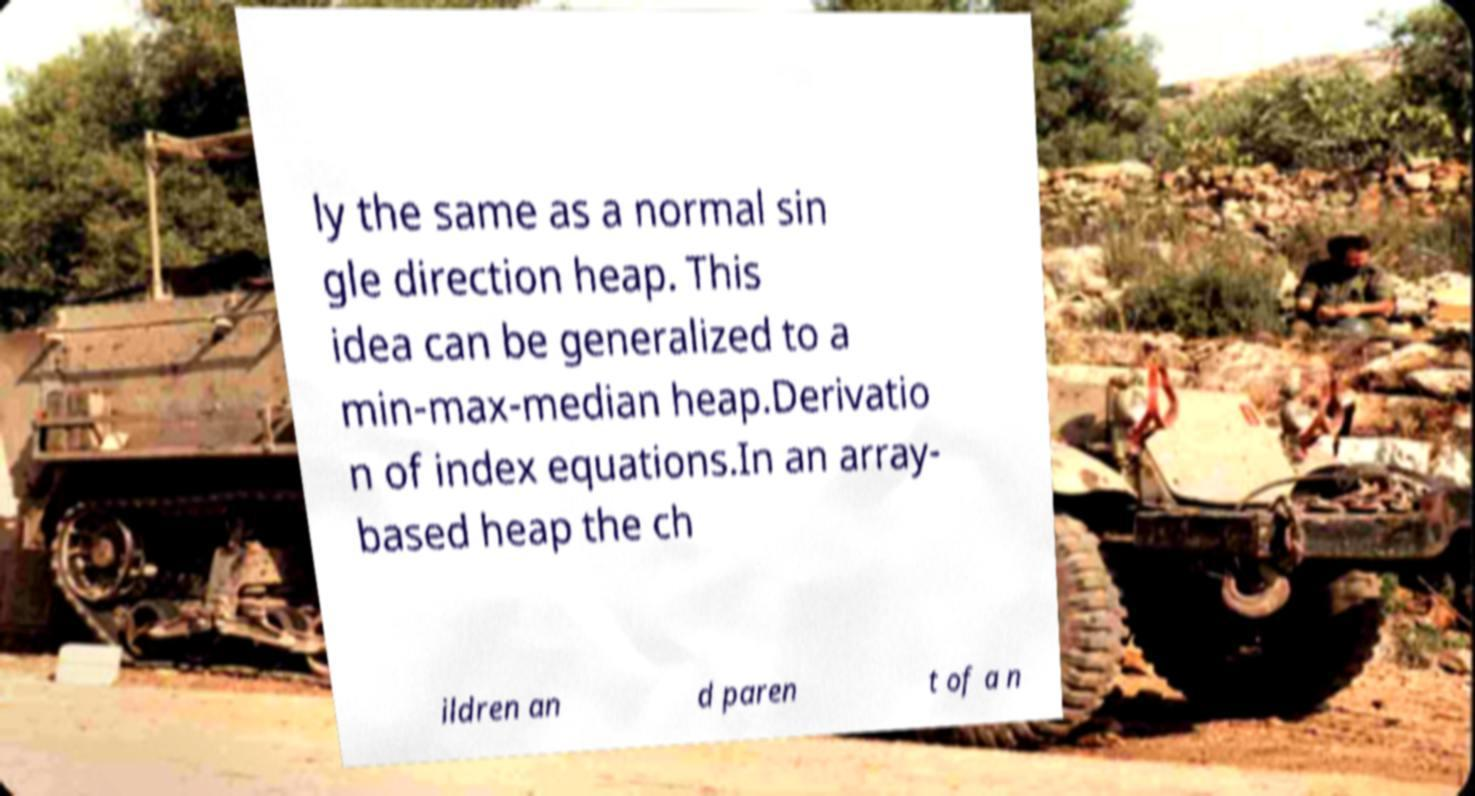Can you accurately transcribe the text from the provided image for me? ly the same as a normal sin gle direction heap. This idea can be generalized to a min-max-median heap.Derivatio n of index equations.In an array- based heap the ch ildren an d paren t of a n 